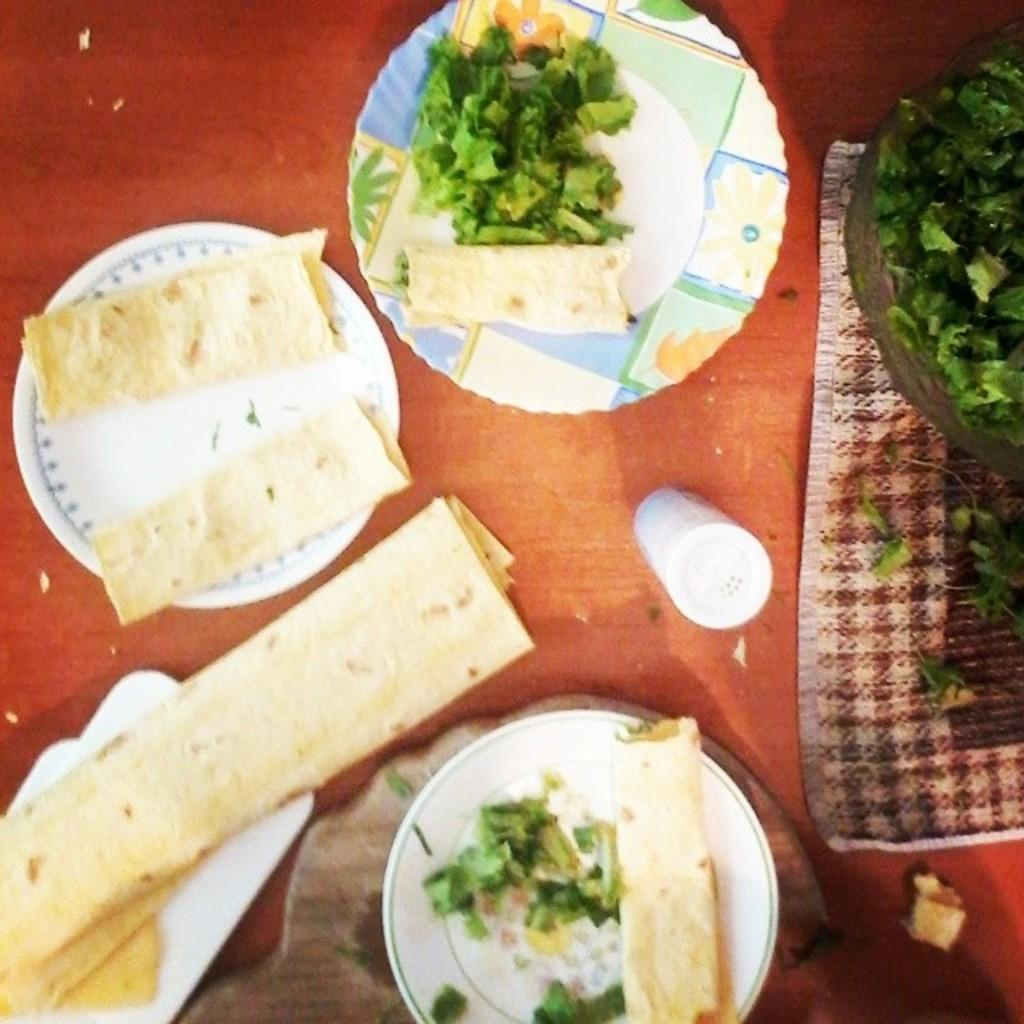What is on the plates in the image? There is food in the plates in the image. What is in the basket in the image? There are leaves in a basket in the image. What type of napkin is present in the image? There is a cloth napkin in the image. What condiment is available on the table in the image? There is a salt shaker on the table in the image. What type of stone is used as a centerpiece in the image? There is no stone present in the image; it features plates with food, a basket with leaves, a cloth napkin, and a salt shaker. How much tax is being paid for the food in the image? There is no information about tax in the image; it only shows the food on the plates. 